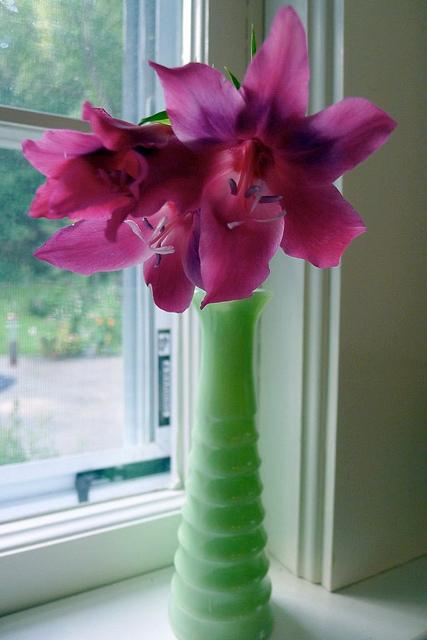What color is the vase?
Answer briefly. Green. Are these roses?
Short answer required. No. How many flowers in the vase?
Quick response, please. 2. 